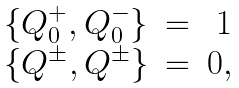<formula> <loc_0><loc_0><loc_500><loc_500>\begin{array} { l c r } \{ Q _ { 0 } ^ { + } , Q _ { 0 } ^ { - } \} & = & 1 \\ \{ Q ^ { \pm } , Q ^ { \pm } \} & = & 0 , \end{array}</formula> 